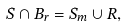Convert formula to latex. <formula><loc_0><loc_0><loc_500><loc_500>S \cap B _ { r } = S _ { m } \cup R ,</formula> 